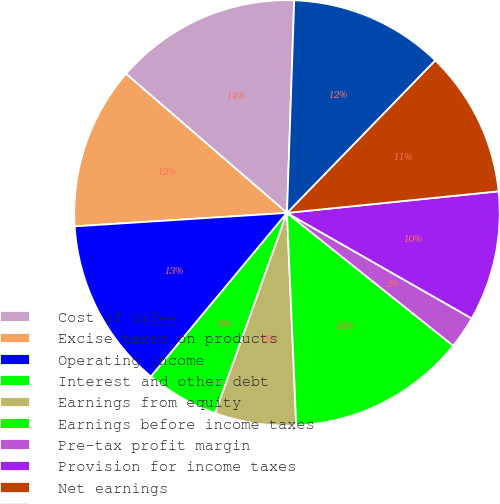Convert chart to OTSL. <chart><loc_0><loc_0><loc_500><loc_500><pie_chart><fcel>Cost of sales<fcel>Excise taxes on products<fcel>Operating income<fcel>Interest and other debt<fcel>Earnings from equity<fcel>Earnings before income taxes<fcel>Pre-tax profit margin<fcel>Provision for income taxes<fcel>Net earnings<fcel>Net earnings attributable to<nl><fcel>14.2%<fcel>12.35%<fcel>12.96%<fcel>5.56%<fcel>6.17%<fcel>13.58%<fcel>2.47%<fcel>9.88%<fcel>11.11%<fcel>11.73%<nl></chart> 